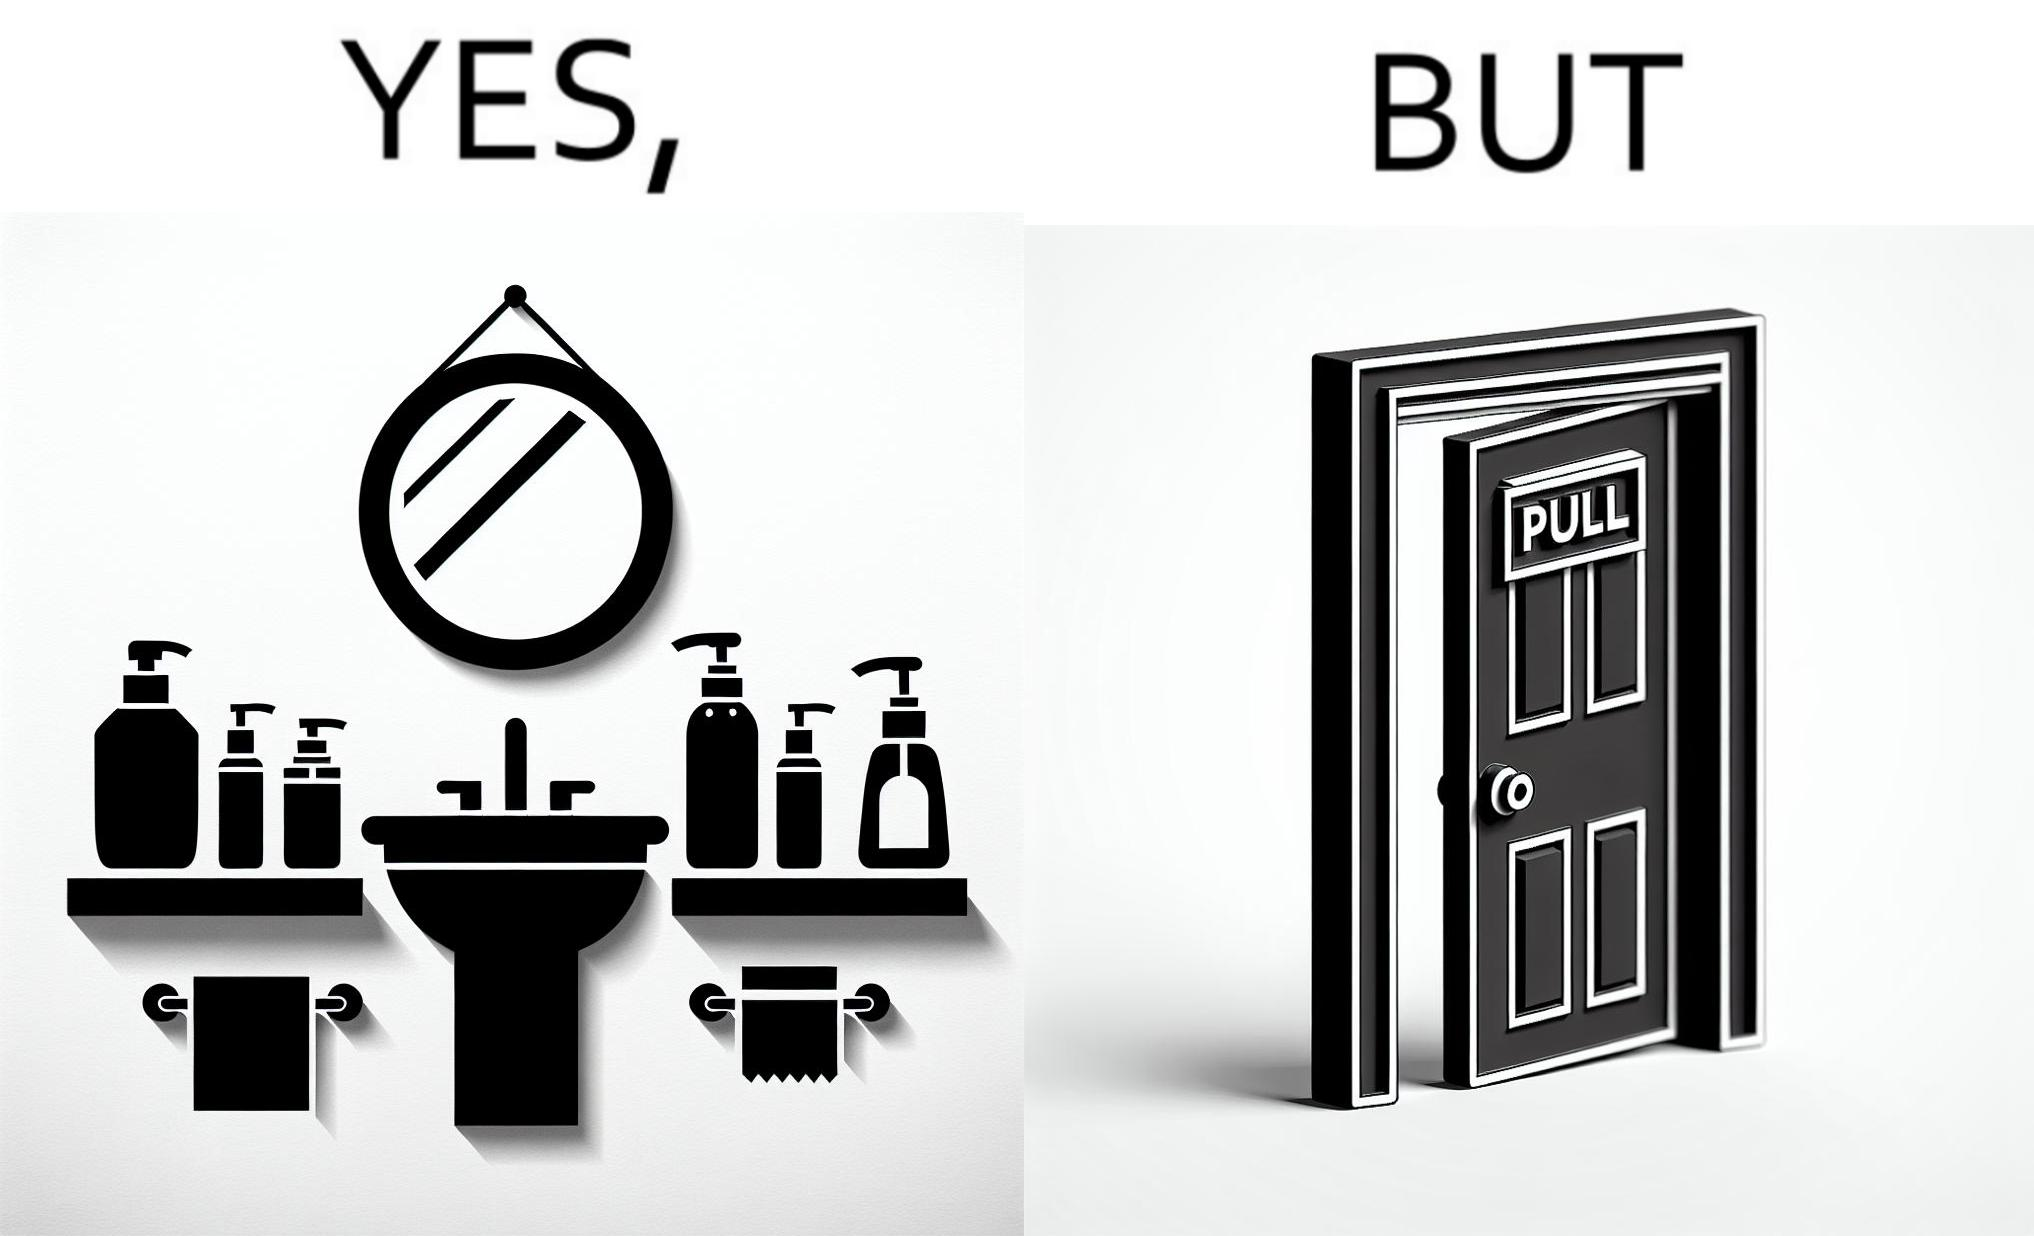What is shown in this image? The image is ironic, because in the first image in the bathroom there are so many things to clean hands around the basin but in the same bathroom people have to open the doors by hand which can easily spread the germs or bacteria even after times of hand cleaning as there is no way to open it without hands 